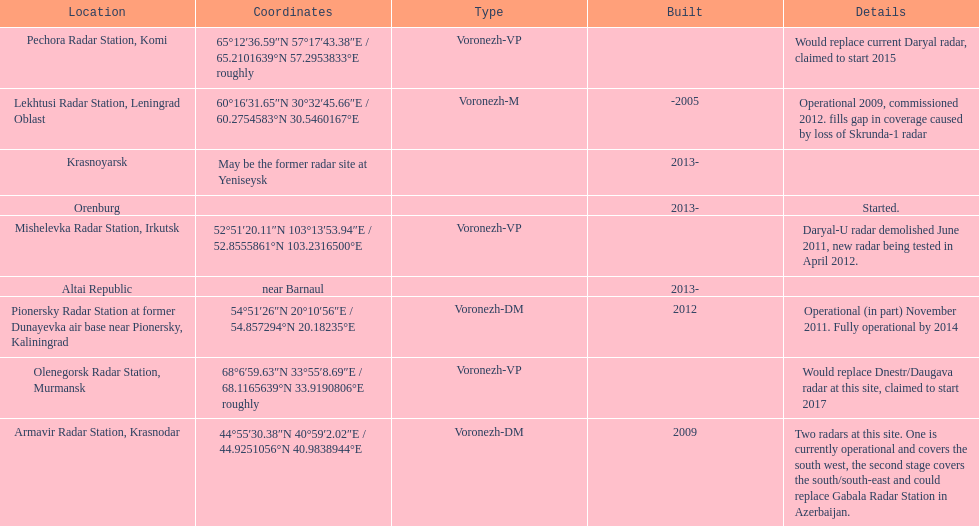Which site has the most radars? Armavir Radar Station, Krasnodar. 